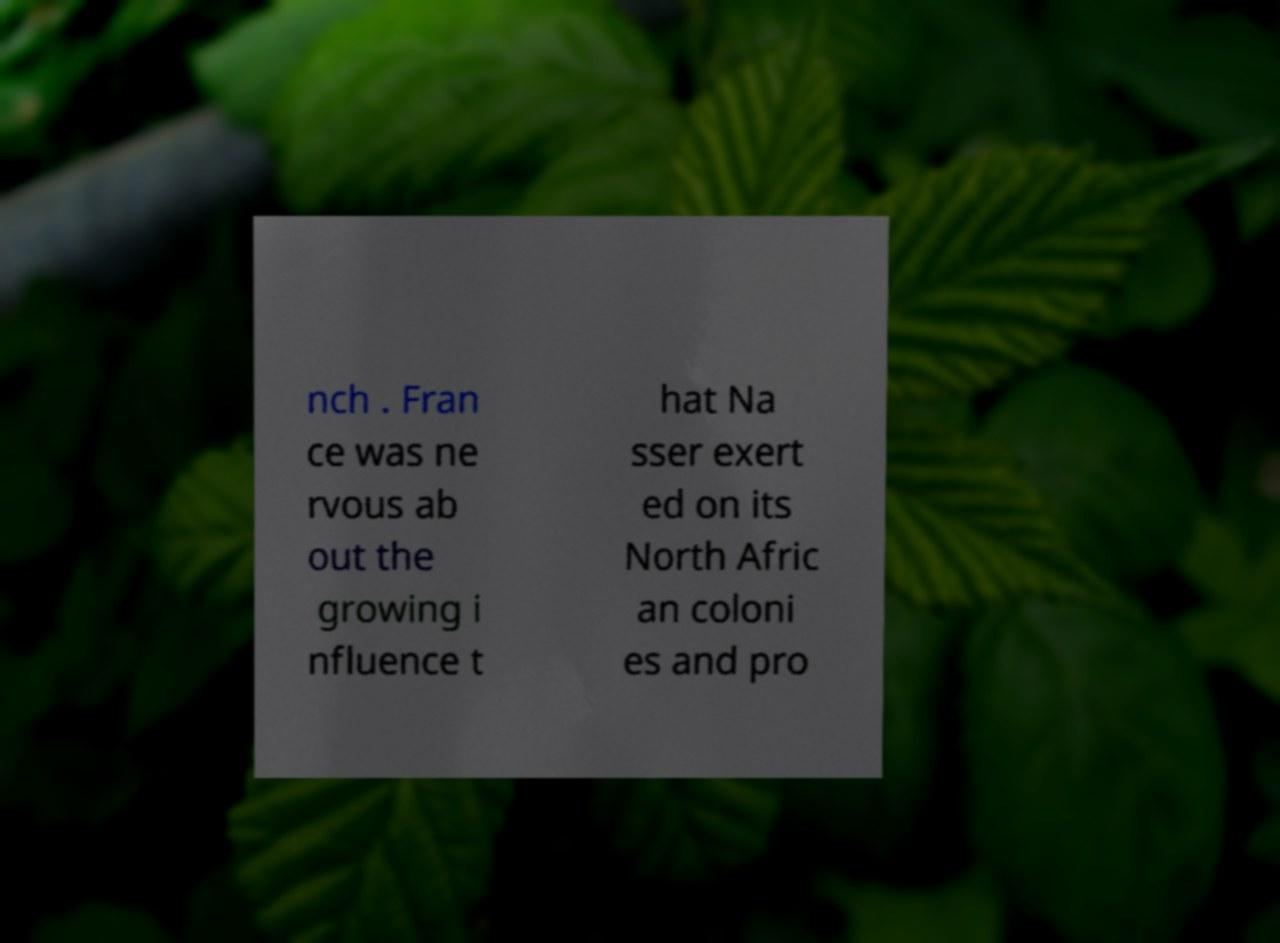Could you extract and type out the text from this image? nch . Fran ce was ne rvous ab out the growing i nfluence t hat Na sser exert ed on its North Afric an coloni es and pro 